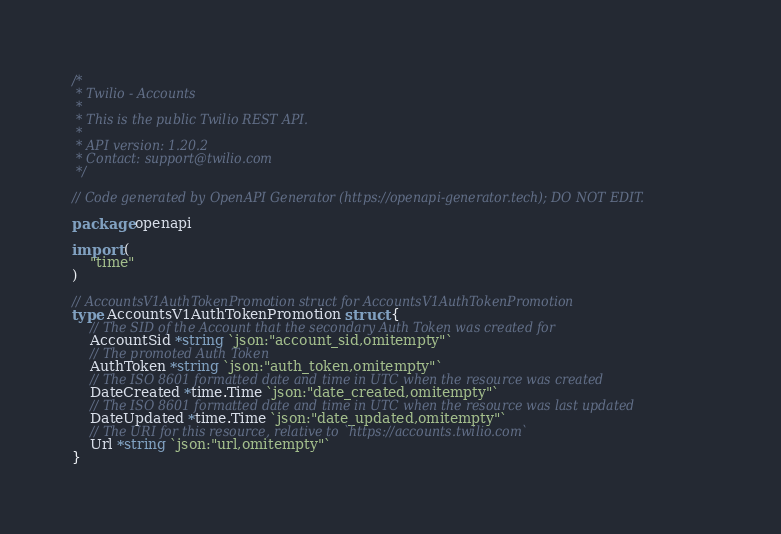Convert code to text. <code><loc_0><loc_0><loc_500><loc_500><_Go_>/*
 * Twilio - Accounts
 *
 * This is the public Twilio REST API.
 *
 * API version: 1.20.2
 * Contact: support@twilio.com
 */

// Code generated by OpenAPI Generator (https://openapi-generator.tech); DO NOT EDIT.

package openapi

import (
	"time"
)

// AccountsV1AuthTokenPromotion struct for AccountsV1AuthTokenPromotion
type AccountsV1AuthTokenPromotion struct {
	// The SID of the Account that the secondary Auth Token was created for
	AccountSid *string `json:"account_sid,omitempty"`
	// The promoted Auth Token
	AuthToken *string `json:"auth_token,omitempty"`
	// The ISO 8601 formatted date and time in UTC when the resource was created
	DateCreated *time.Time `json:"date_created,omitempty"`
	// The ISO 8601 formatted date and time in UTC when the resource was last updated
	DateUpdated *time.Time `json:"date_updated,omitempty"`
	// The URI for this resource, relative to `https://accounts.twilio.com`
	Url *string `json:"url,omitempty"`
}
</code> 